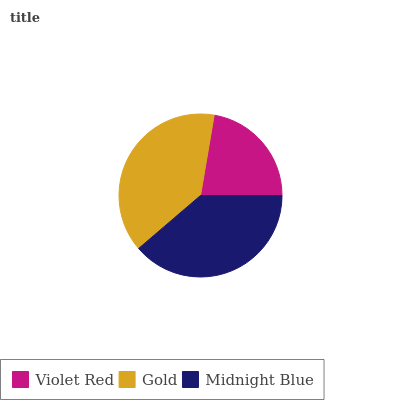Is Violet Red the minimum?
Answer yes or no. Yes. Is Gold the maximum?
Answer yes or no. Yes. Is Midnight Blue the minimum?
Answer yes or no. No. Is Midnight Blue the maximum?
Answer yes or no. No. Is Gold greater than Midnight Blue?
Answer yes or no. Yes. Is Midnight Blue less than Gold?
Answer yes or no. Yes. Is Midnight Blue greater than Gold?
Answer yes or no. No. Is Gold less than Midnight Blue?
Answer yes or no. No. Is Midnight Blue the high median?
Answer yes or no. Yes. Is Midnight Blue the low median?
Answer yes or no. Yes. Is Violet Red the high median?
Answer yes or no. No. Is Violet Red the low median?
Answer yes or no. No. 